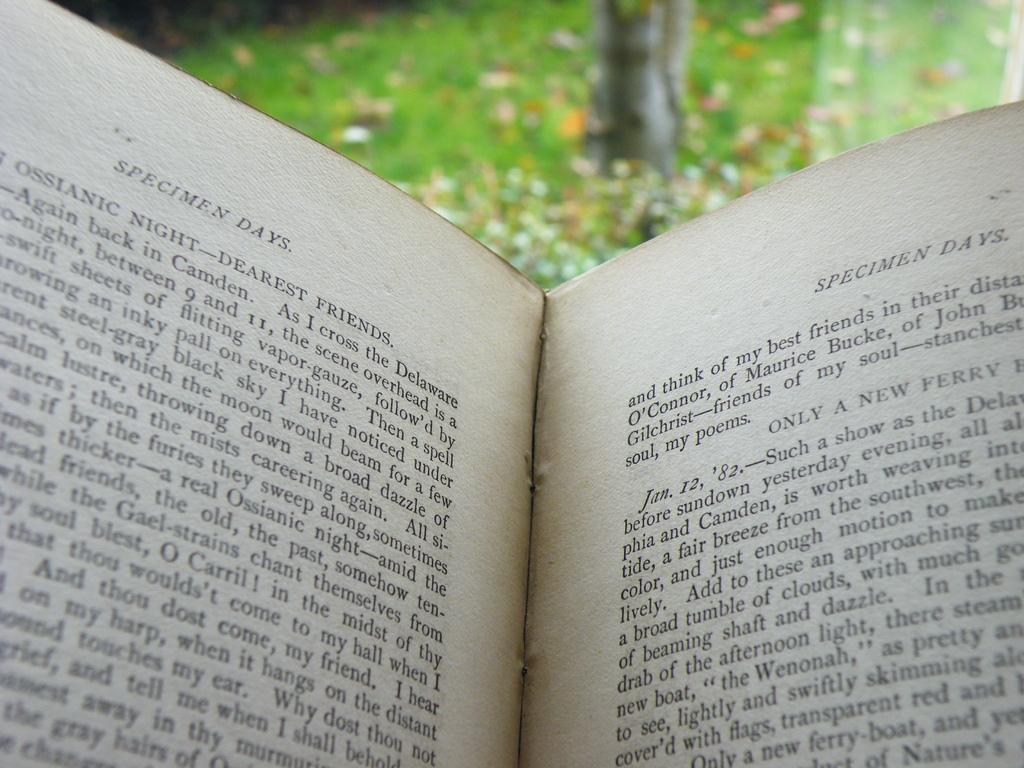<image>
Relay a brief, clear account of the picture shown. a open book with the words Specimen Days at the top of it 